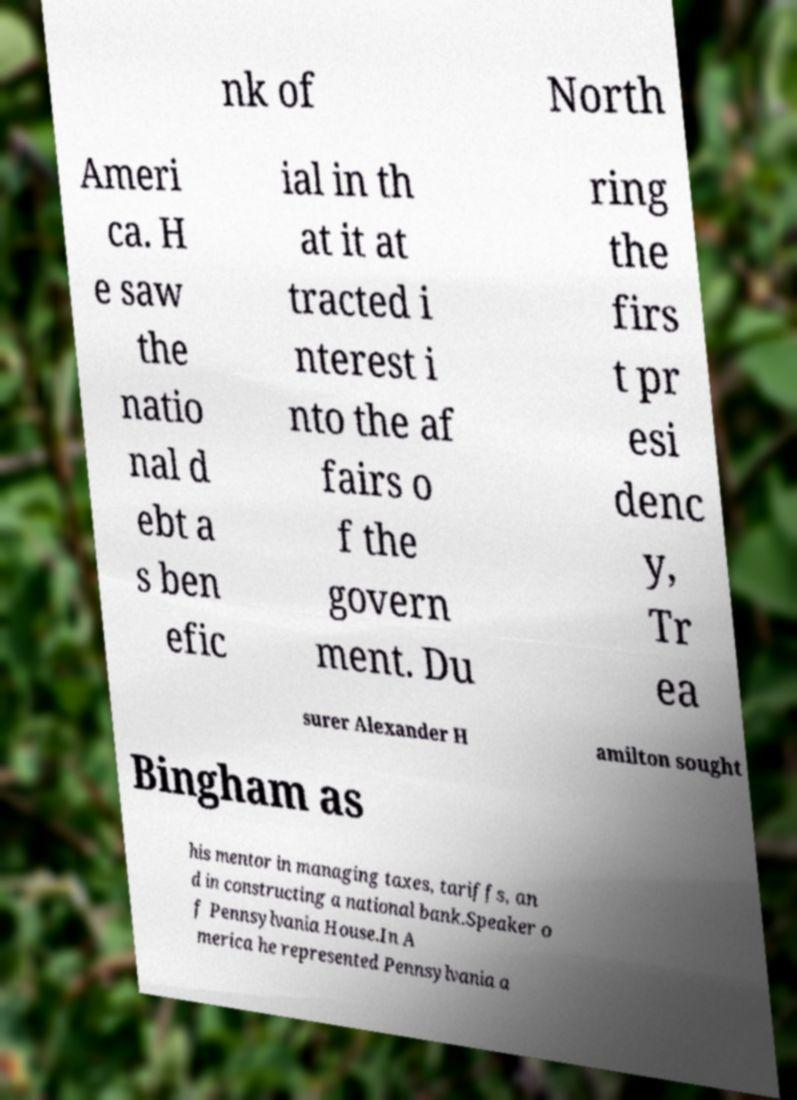Please identify and transcribe the text found in this image. nk of North Ameri ca. H e saw the natio nal d ebt a s ben efic ial in th at it at tracted i nterest i nto the af fairs o f the govern ment. Du ring the firs t pr esi denc y, Tr ea surer Alexander H amilton sought Bingham as his mentor in managing taxes, tariffs, an d in constructing a national bank.Speaker o f Pennsylvania House.In A merica he represented Pennsylvania a 